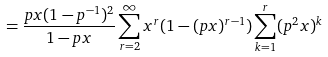<formula> <loc_0><loc_0><loc_500><loc_500>= \frac { p x ( 1 - p ^ { - 1 } ) ^ { 2 } } { 1 - p x } \sum _ { r = 2 } ^ { \infty } x ^ { r } ( 1 - ( p x ) ^ { r - 1 } ) \sum _ { k = 1 } ^ { r } ( p ^ { 2 } x ) ^ { k }</formula> 